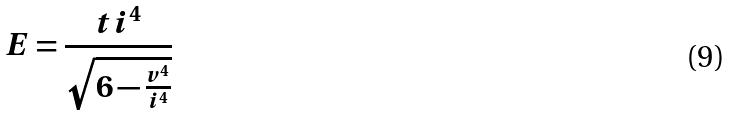<formula> <loc_0><loc_0><loc_500><loc_500>E = \frac { t i ^ { 4 } } { \sqrt { 6 - \frac { v ^ { 4 } } { i ^ { 4 } } } }</formula> 